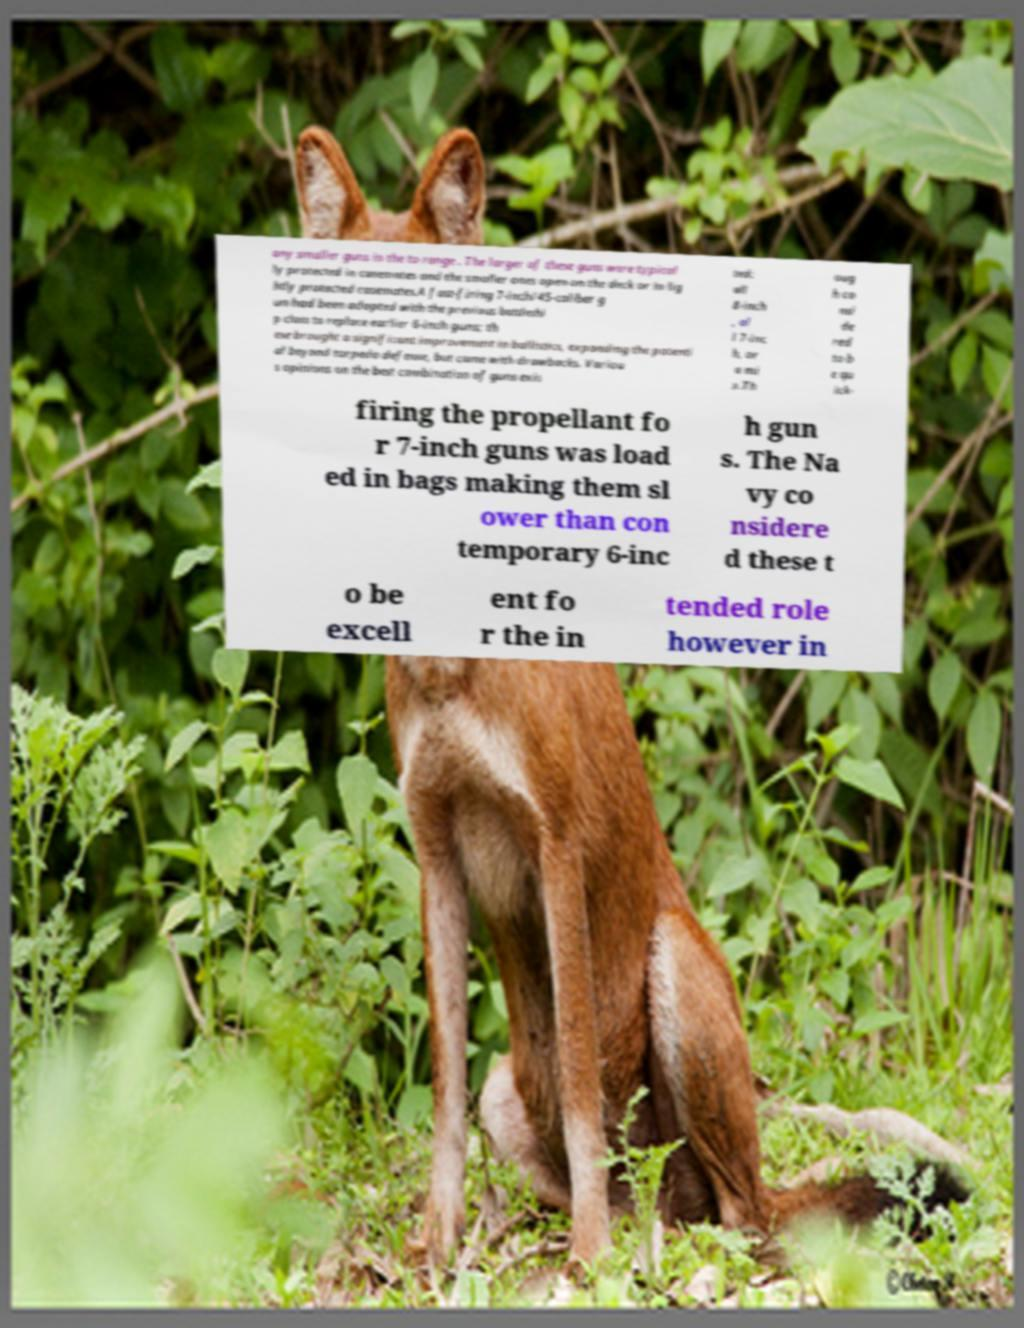For documentation purposes, I need the text within this image transcribed. Could you provide that? any smaller guns in the to range . The larger of these guns were typical ly protected in casemates and the smaller ones open on the deck or in lig htly protected casemates.A fast-firing 7-inch/45-caliber g un had been adopted with the previous battleshi p class to replace earlier 6-inch guns; th ese brought a significant improvement in ballistics, expanding the potenti al beyond torpedo defense, but came with drawbacks. Variou s opinions on the best combination of guns exis ted: all 8-inch , al l 7-inc h, or a mi x.Th oug h co nsi de red to b e qu ick- firing the propellant fo r 7-inch guns was load ed in bags making them sl ower than con temporary 6-inc h gun s. The Na vy co nsidere d these t o be excell ent fo r the in tended role however in 